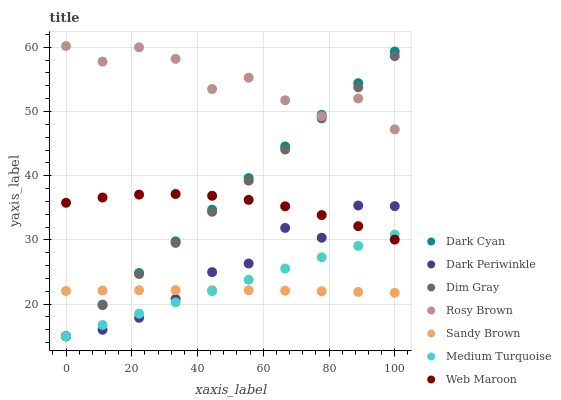Does Sandy Brown have the minimum area under the curve?
Answer yes or no. Yes. Does Rosy Brown have the maximum area under the curve?
Answer yes or no. Yes. Does Web Maroon have the minimum area under the curve?
Answer yes or no. No. Does Web Maroon have the maximum area under the curve?
Answer yes or no. No. Is Dim Gray the smoothest?
Answer yes or no. Yes. Is Rosy Brown the roughest?
Answer yes or no. Yes. Is Web Maroon the smoothest?
Answer yes or no. No. Is Web Maroon the roughest?
Answer yes or no. No. Does Dim Gray have the lowest value?
Answer yes or no. Yes. Does Web Maroon have the lowest value?
Answer yes or no. No. Does Rosy Brown have the highest value?
Answer yes or no. Yes. Does Web Maroon have the highest value?
Answer yes or no. No. Is Web Maroon less than Rosy Brown?
Answer yes or no. Yes. Is Rosy Brown greater than Sandy Brown?
Answer yes or no. Yes. Does Medium Turquoise intersect Sandy Brown?
Answer yes or no. Yes. Is Medium Turquoise less than Sandy Brown?
Answer yes or no. No. Is Medium Turquoise greater than Sandy Brown?
Answer yes or no. No. Does Web Maroon intersect Rosy Brown?
Answer yes or no. No. 